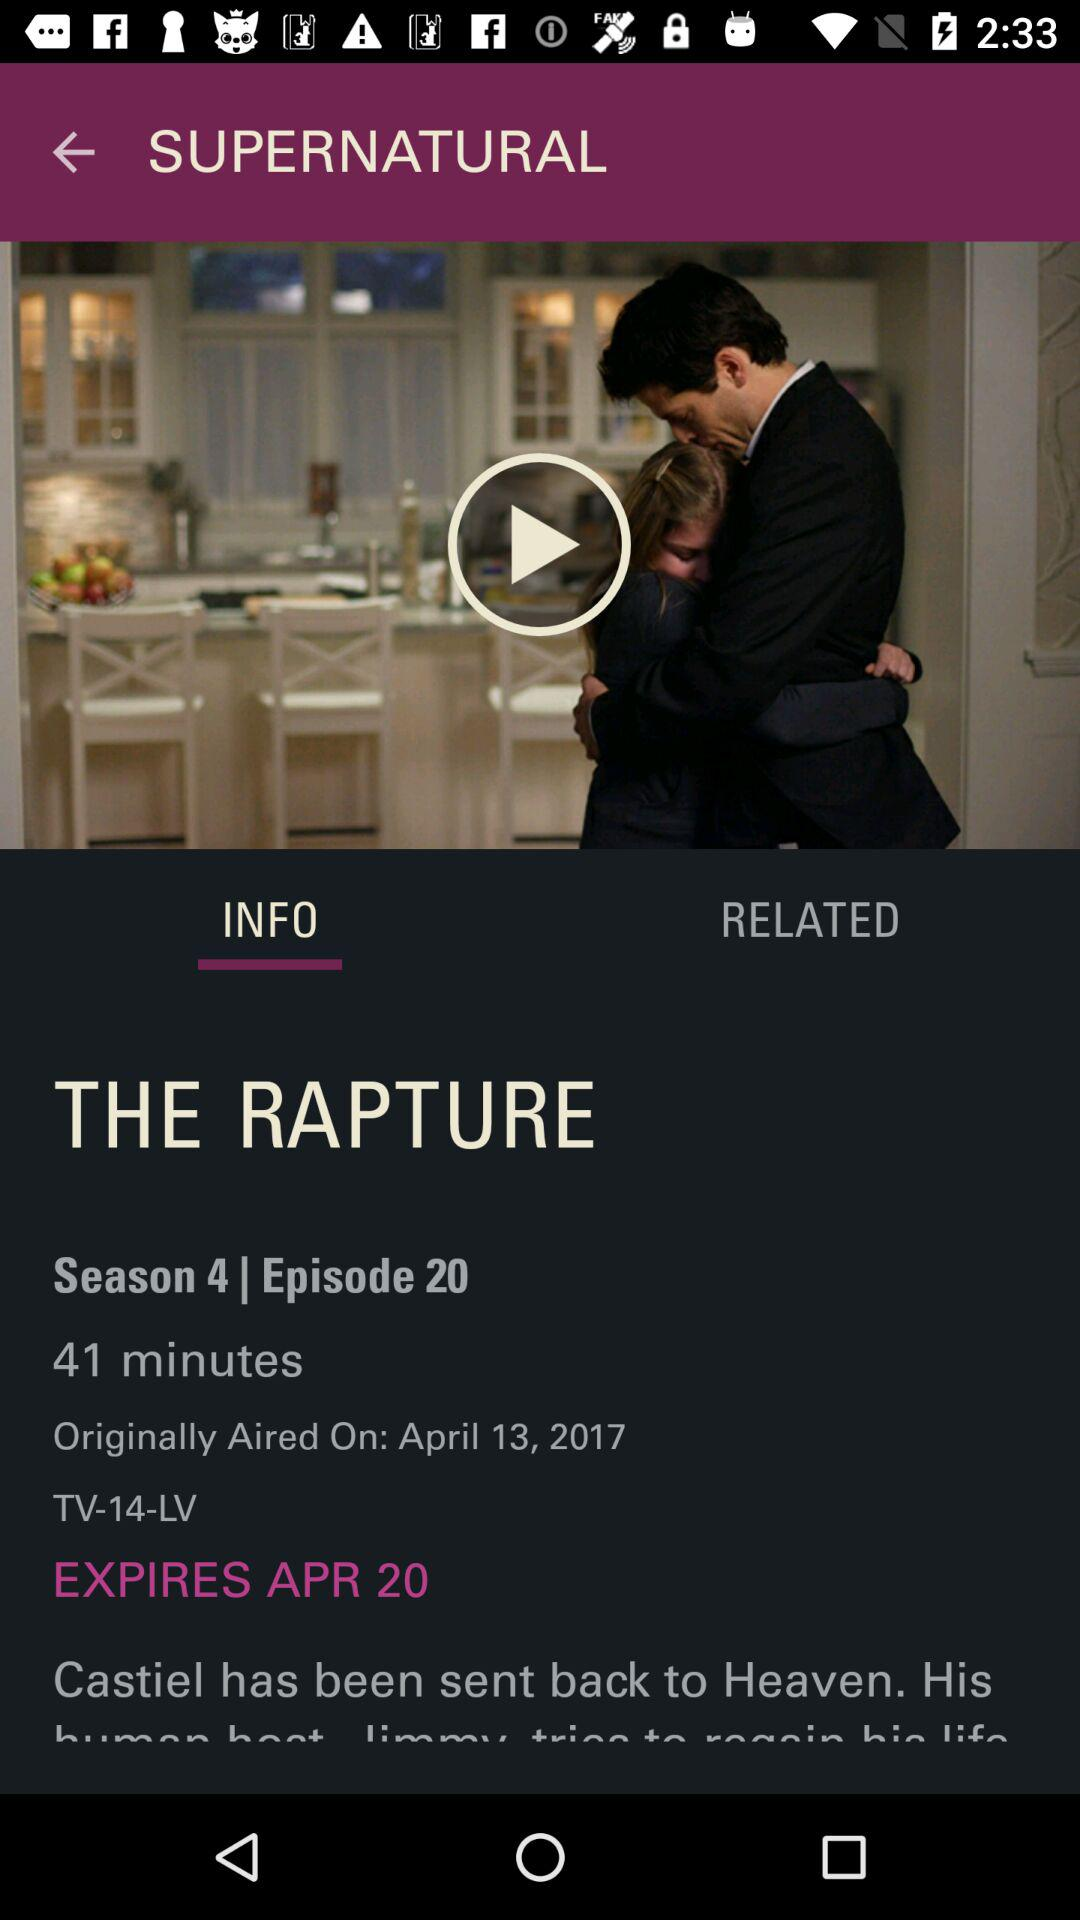On which date was episode 20 released? Episode 20 was released on April 13, 2017. 